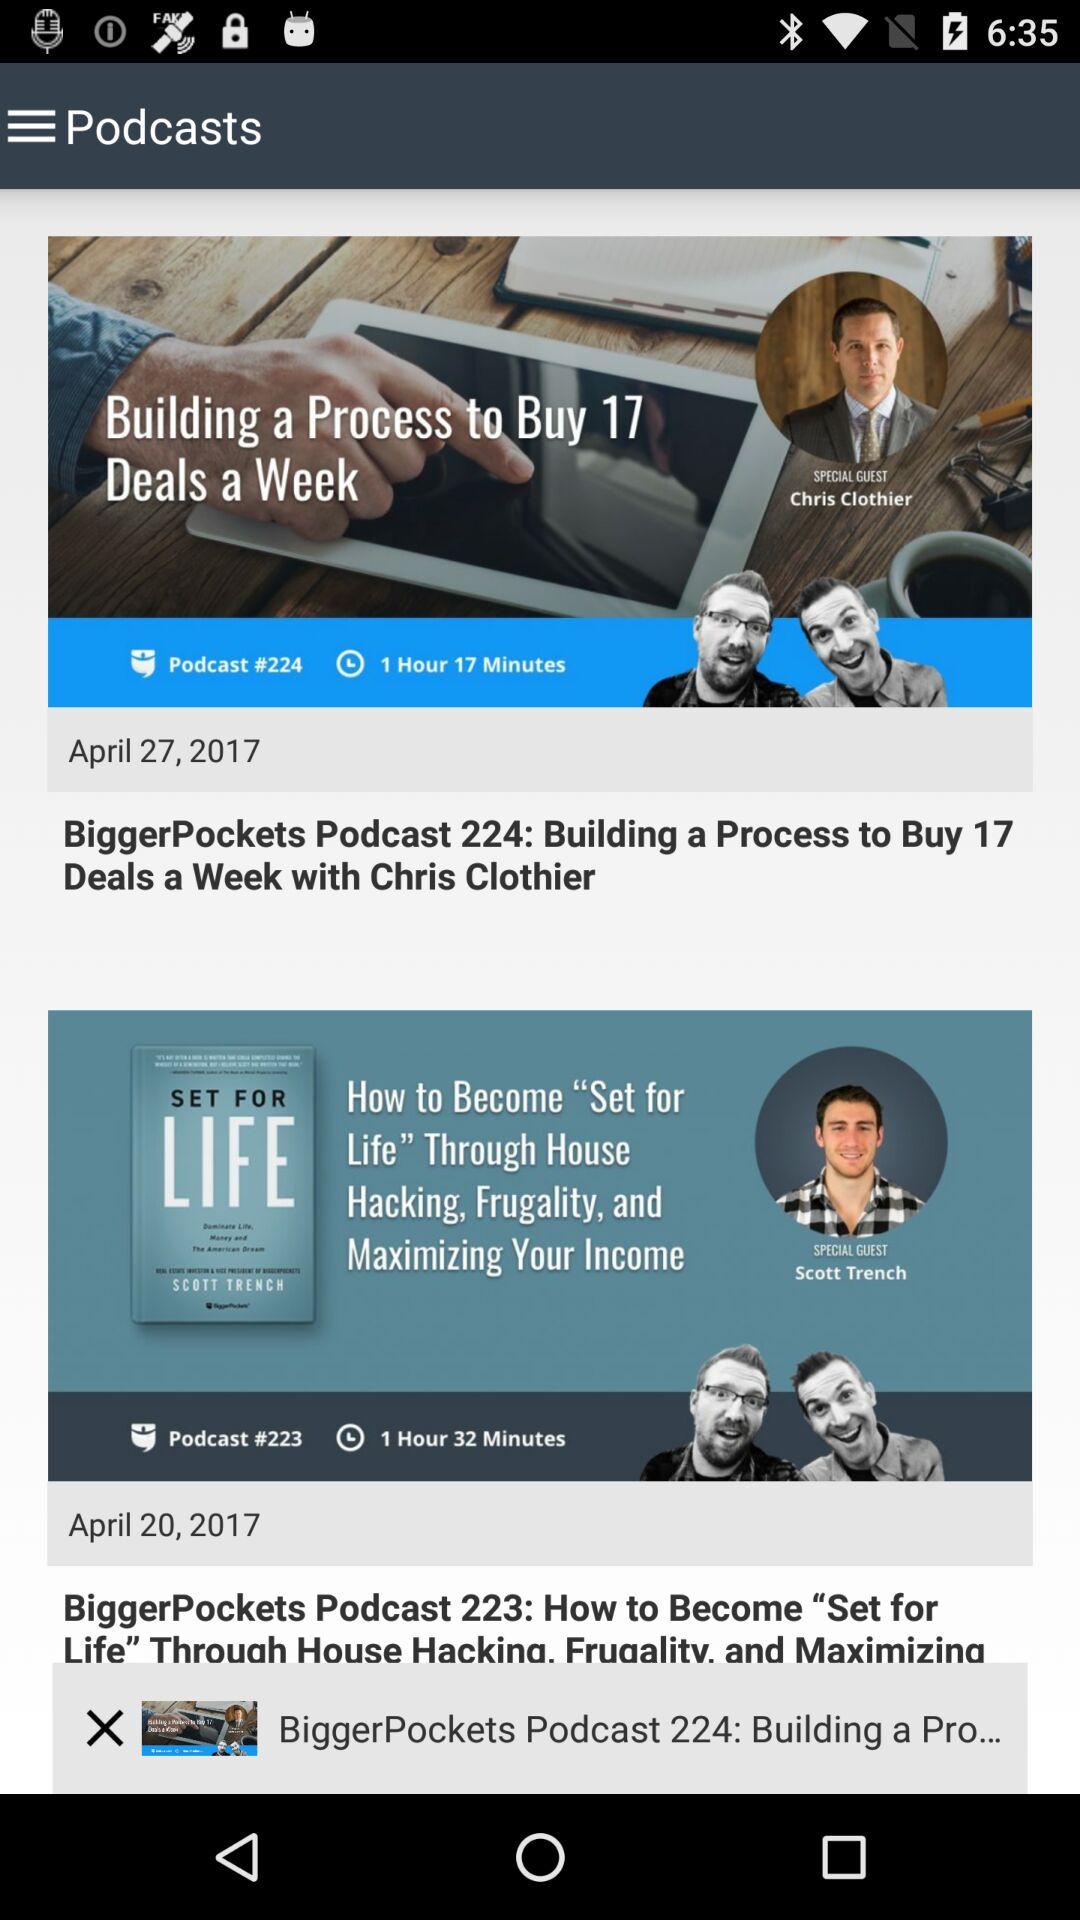What is the time duration of "BiggerPockets Podcast 223: How to Become "Set for Life" Through House Hacking, Frugality, and Maximizing Your Income"? The time duration is 1 hour and 32 minutes. 